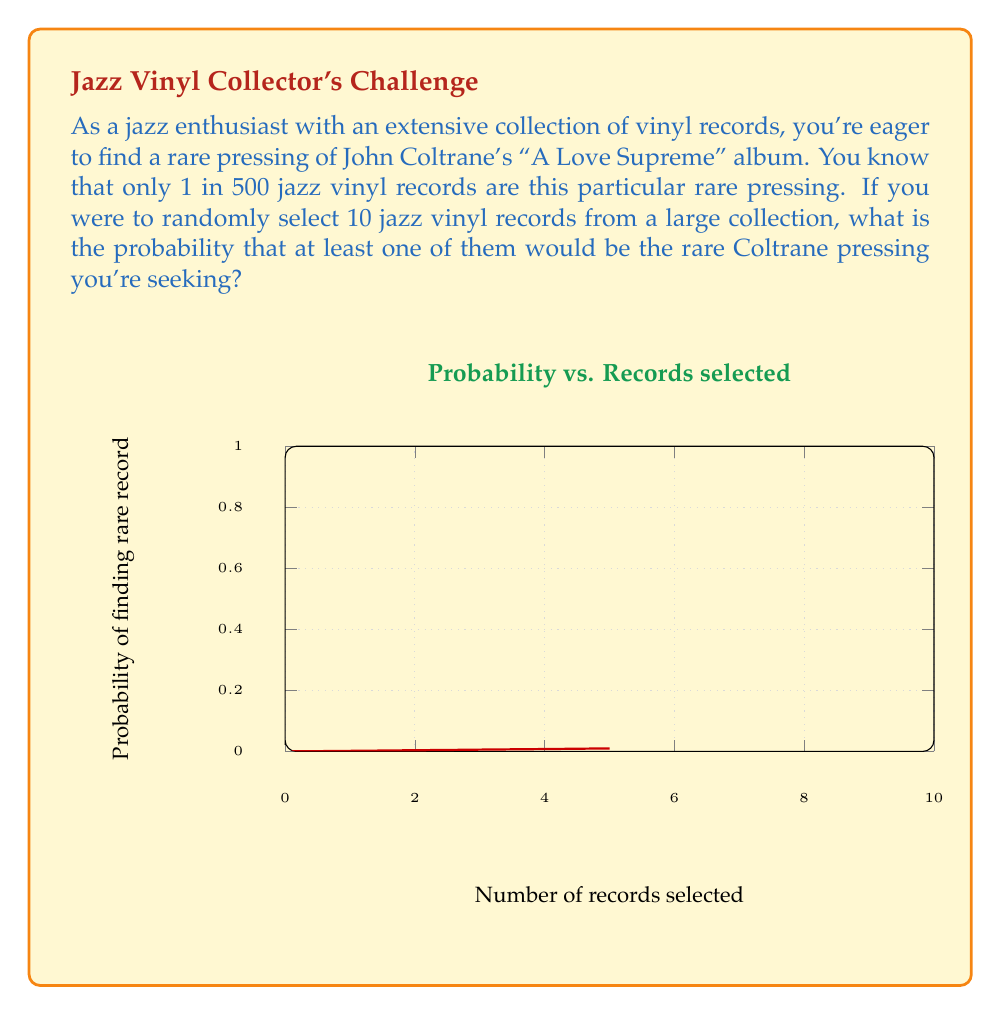Could you help me with this problem? Let's approach this step-by-step:

1) First, let's consider the probability of not selecting the rare record in a single draw:
   $$P(\text{not rare}) = 1 - \frac{1}{500} = 0.998$$

2) For 10 independent selections, the probability of not getting the rare record in any of them is:
   $$P(\text{all not rare}) = (0.998)^{10}$$

3) Therefore, the probability of getting at least one rare record is the complement of this:
   $$P(\text{at least one rare}) = 1 - P(\text{all not rare}) = 1 - (0.998)^{10}$$

4) Let's calculate this:
   $$1 - (0.998)^{10} = 1 - 0.9801 = 0.0199$$

5) This can be expressed as a percentage:
   $$0.0199 \times 100\% = 1.99\%$$

This problem demonstrates the use of the complement rule in probability and the concept of independent events. The graph in the question illustrates how this probability increases with the number of records selected, which might resonate with our jazz enthusiast's experience of searching through many records to find a rare gem.
Answer: $1.99\%$ 